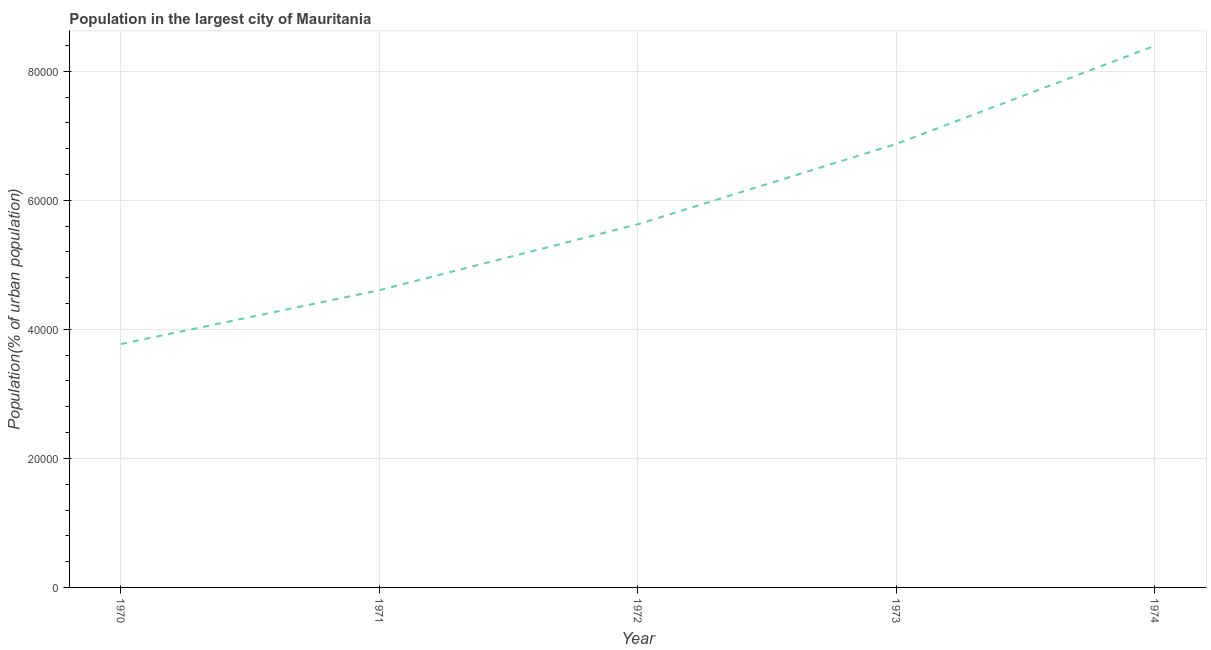What is the population in largest city in 1974?
Give a very brief answer. 8.40e+04. Across all years, what is the maximum population in largest city?
Give a very brief answer. 8.40e+04. Across all years, what is the minimum population in largest city?
Give a very brief answer. 3.77e+04. In which year was the population in largest city maximum?
Provide a short and direct response. 1974. What is the sum of the population in largest city?
Your answer should be compact. 2.93e+05. What is the difference between the population in largest city in 1971 and 1973?
Your answer should be very brief. -2.27e+04. What is the average population in largest city per year?
Make the answer very short. 5.86e+04. What is the median population in largest city?
Your response must be concise. 5.63e+04. What is the ratio of the population in largest city in 1972 to that in 1974?
Your response must be concise. 0.67. Is the population in largest city in 1972 less than that in 1974?
Provide a short and direct response. Yes. Is the difference between the population in largest city in 1973 and 1974 greater than the difference between any two years?
Provide a succinct answer. No. What is the difference between the highest and the second highest population in largest city?
Ensure brevity in your answer.  1.52e+04. What is the difference between the highest and the lowest population in largest city?
Your answer should be compact. 4.62e+04. In how many years, is the population in largest city greater than the average population in largest city taken over all years?
Provide a succinct answer. 2. Does the population in largest city monotonically increase over the years?
Make the answer very short. Yes. What is the difference between two consecutive major ticks on the Y-axis?
Your answer should be very brief. 2.00e+04. Are the values on the major ticks of Y-axis written in scientific E-notation?
Your response must be concise. No. Does the graph contain any zero values?
Your answer should be compact. No. What is the title of the graph?
Your answer should be compact. Population in the largest city of Mauritania. What is the label or title of the X-axis?
Ensure brevity in your answer.  Year. What is the label or title of the Y-axis?
Offer a very short reply. Population(% of urban population). What is the Population(% of urban population) of 1970?
Provide a succinct answer. 3.77e+04. What is the Population(% of urban population) in 1971?
Your answer should be very brief. 4.61e+04. What is the Population(% of urban population) of 1972?
Provide a succinct answer. 5.63e+04. What is the Population(% of urban population) of 1973?
Offer a very short reply. 6.87e+04. What is the Population(% of urban population) in 1974?
Offer a very short reply. 8.40e+04. What is the difference between the Population(% of urban population) in 1970 and 1971?
Your answer should be very brief. -8352. What is the difference between the Population(% of urban population) in 1970 and 1972?
Your response must be concise. -1.86e+04. What is the difference between the Population(% of urban population) in 1970 and 1973?
Offer a terse response. -3.10e+04. What is the difference between the Population(% of urban population) in 1970 and 1974?
Your answer should be compact. -4.62e+04. What is the difference between the Population(% of urban population) in 1971 and 1972?
Offer a terse response. -1.02e+04. What is the difference between the Population(% of urban population) in 1971 and 1973?
Make the answer very short. -2.27e+04. What is the difference between the Population(% of urban population) in 1971 and 1974?
Keep it short and to the point. -3.79e+04. What is the difference between the Population(% of urban population) in 1972 and 1973?
Provide a succinct answer. -1.24e+04. What is the difference between the Population(% of urban population) in 1972 and 1974?
Your answer should be compact. -2.77e+04. What is the difference between the Population(% of urban population) in 1973 and 1974?
Offer a terse response. -1.52e+04. What is the ratio of the Population(% of urban population) in 1970 to that in 1971?
Make the answer very short. 0.82. What is the ratio of the Population(% of urban population) in 1970 to that in 1972?
Provide a short and direct response. 0.67. What is the ratio of the Population(% of urban population) in 1970 to that in 1973?
Give a very brief answer. 0.55. What is the ratio of the Population(% of urban population) in 1970 to that in 1974?
Your answer should be compact. 0.45. What is the ratio of the Population(% of urban population) in 1971 to that in 1972?
Offer a very short reply. 0.82. What is the ratio of the Population(% of urban population) in 1971 to that in 1973?
Ensure brevity in your answer.  0.67. What is the ratio of the Population(% of urban population) in 1971 to that in 1974?
Your answer should be very brief. 0.55. What is the ratio of the Population(% of urban population) in 1972 to that in 1973?
Your answer should be very brief. 0.82. What is the ratio of the Population(% of urban population) in 1972 to that in 1974?
Your response must be concise. 0.67. What is the ratio of the Population(% of urban population) in 1973 to that in 1974?
Your response must be concise. 0.82. 